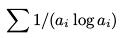Convert formula to latex. <formula><loc_0><loc_0><loc_500><loc_500>\sum 1 / ( a _ { i } \log a _ { i } )</formula> 